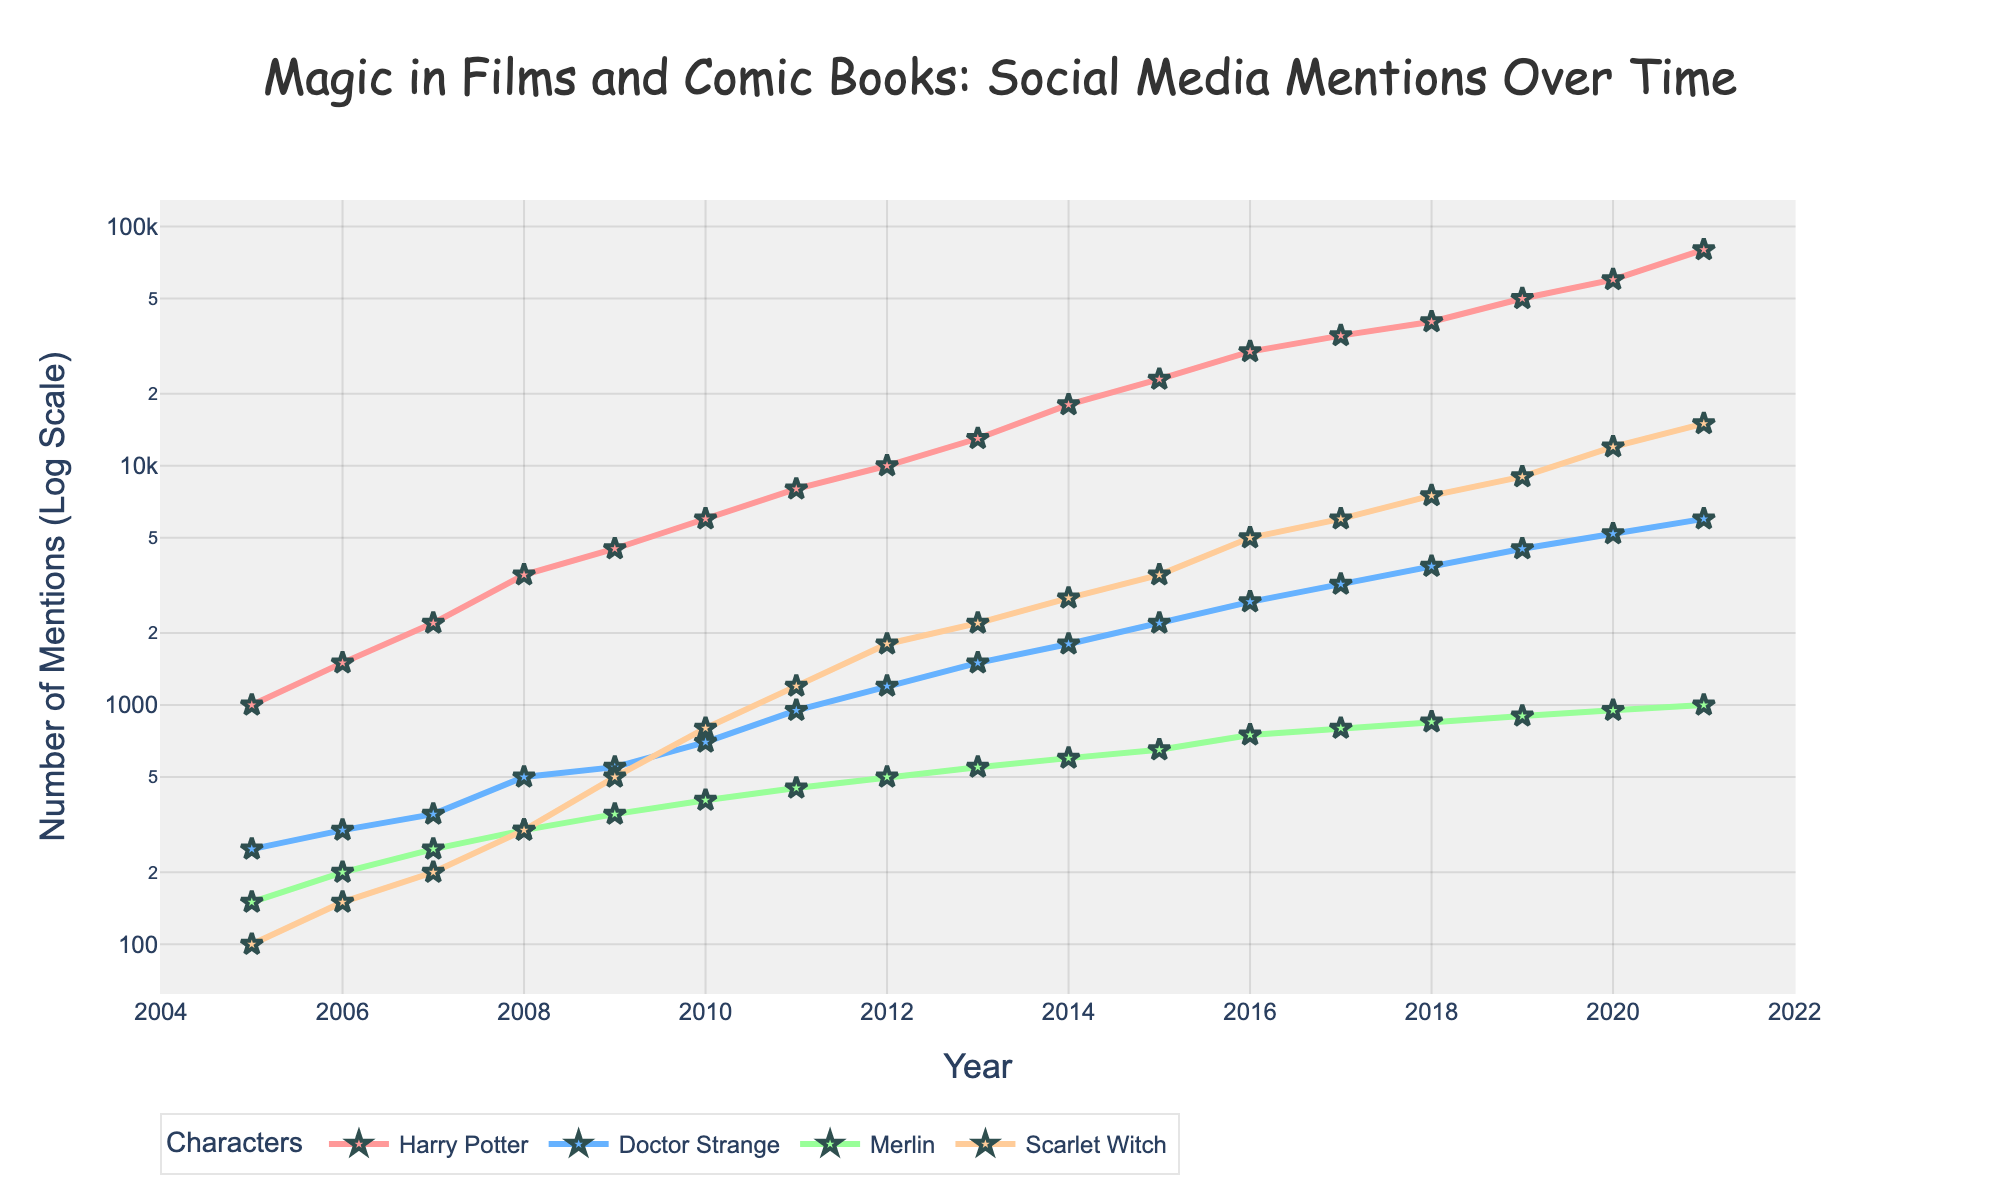What is the title of the plot? The title of the plot is prominently displayed at the top of the plot and reads: "Magic in Films and Comic Books: Social Media Mentions Over Time".
Answer: Magic in Films and Comic Books: Social Media Mentions Over Time Which character had the most social media mentions by 2021? Looking at the highest point in the graph for the year 2021, we see that Harry Potter has the most mentions, reaching 80,000.
Answer: Harry Potter Between which two years did Doctor Strange see the most significant increase in mentions? By inspecting the slope of the line representing Doctor Strange, the most significant increase appears between 2015 and 2016, where the mentions jump from 2,200 to 2,700.
Answer: 2015 and 2016 What is the color of the line representing Merlin's social media mentions? Merlin's line is represented in green.
Answer: Green By how much did Scarlet Witch mentions increase from 2014 to 2018? In 2014, Scarlet Witch had 2,800 mentions, and in 2018, it reached 7,500. The increase is 7,500 - 2,800 = 4,700.
Answer: 4,700 Which character experienced the steepest rise in mentions around 2020? Observing the slope of the lines around 2020, Harry Potter's line steeply rises compared to the others, indicating the steepest increase from 2019 to 2020.
Answer: Harry Potter At which year did mentions for Merlin reach 600? Looking at the Merlin line, mentions reach 600 in the year 2014.
Answer: 2014 Comparing Doctor Strange and Scarlet Witch, who had more mentions in 2013? In 2013, Doctor Strange had 1,500 mentions, while Scarlet Witch had 2,200 mentions, so Scarlet Witch had more.
Answer: Scarlet Witch How do the y-axis tick marks change in a log scale plot? In a log scale plot, the y-axis tick marks represent orders of magnitude rather than linear steps, increasing logarithmically, commonly in multiples of 10.
Answer: Logarithmic scale Between 2019 and 2021, which two characters' mentions rose to 9600 and 10300 respectively? From 2019 to 2021, mentions for Scarlet Witch rose to 9000 in 2019 and then to 12000 in 2020, reaching 15000 in 2021. Doctor Strange mentions increased from 4500 in 2019 to 6000 by 2021. The ones closest to the given numbers are Scarlet Witch and Doctor Strange.
Answer: Scarlet Witch and Doctor Strange 